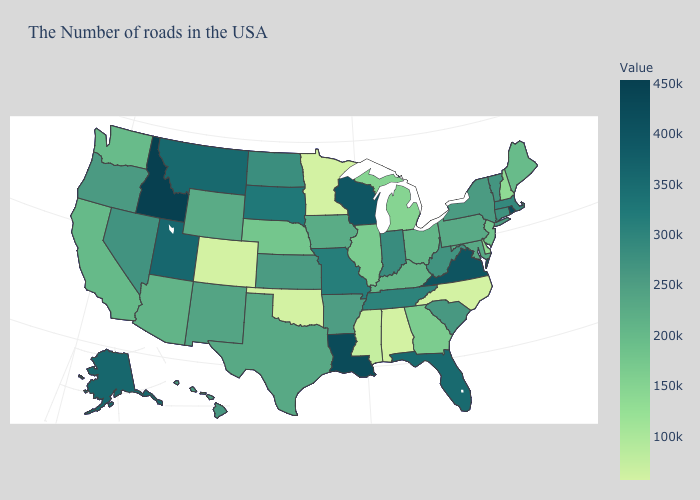Does the map have missing data?
Short answer required. No. Which states hav the highest value in the West?
Concise answer only. Idaho. Does North Carolina have the highest value in the South?
Quick response, please. No. Does Georgia have a lower value than Alabama?
Quick response, please. No. Does Idaho have the highest value in the USA?
Short answer required. Yes. Does the map have missing data?
Be succinct. No. Among the states that border Georgia , which have the highest value?
Quick response, please. Florida. 